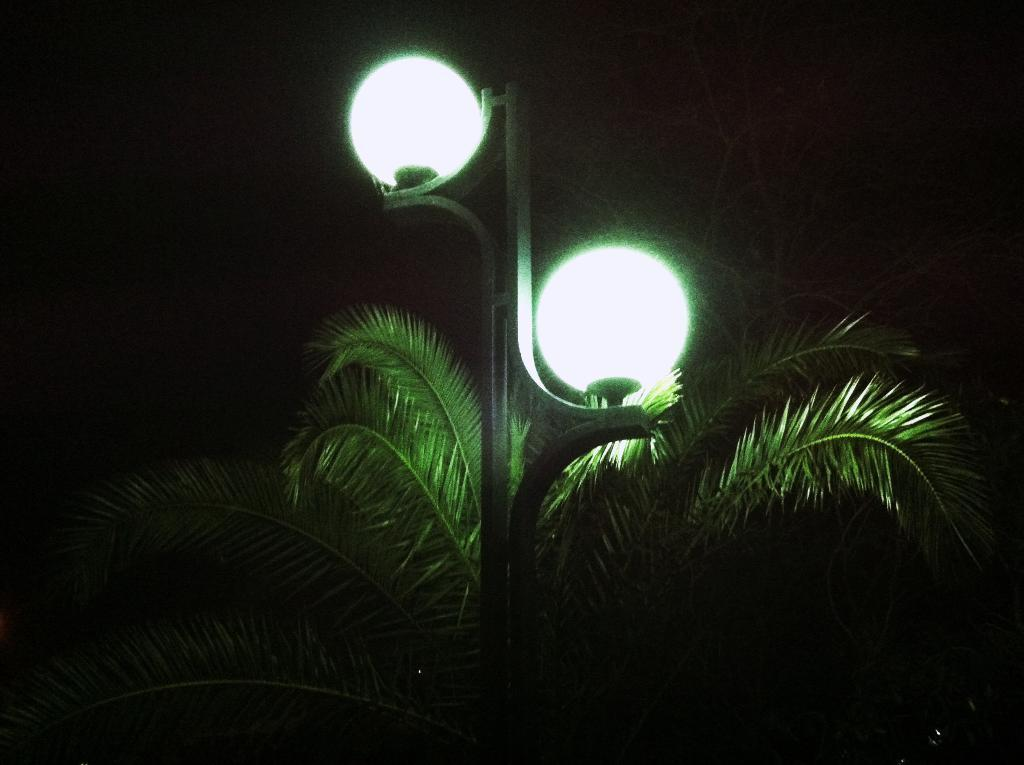What structure can be seen in the image? There is a lamp pole in the image. What natural element is present in the center of the image? There is a tree in the center of the image. What type of jewel can be seen hanging from the tree in the image? There is no jewel present in the image; it features a lamp pole and a tree. What smell can be detected from the image? The image does not convey any smells, as it is a visual representation. 